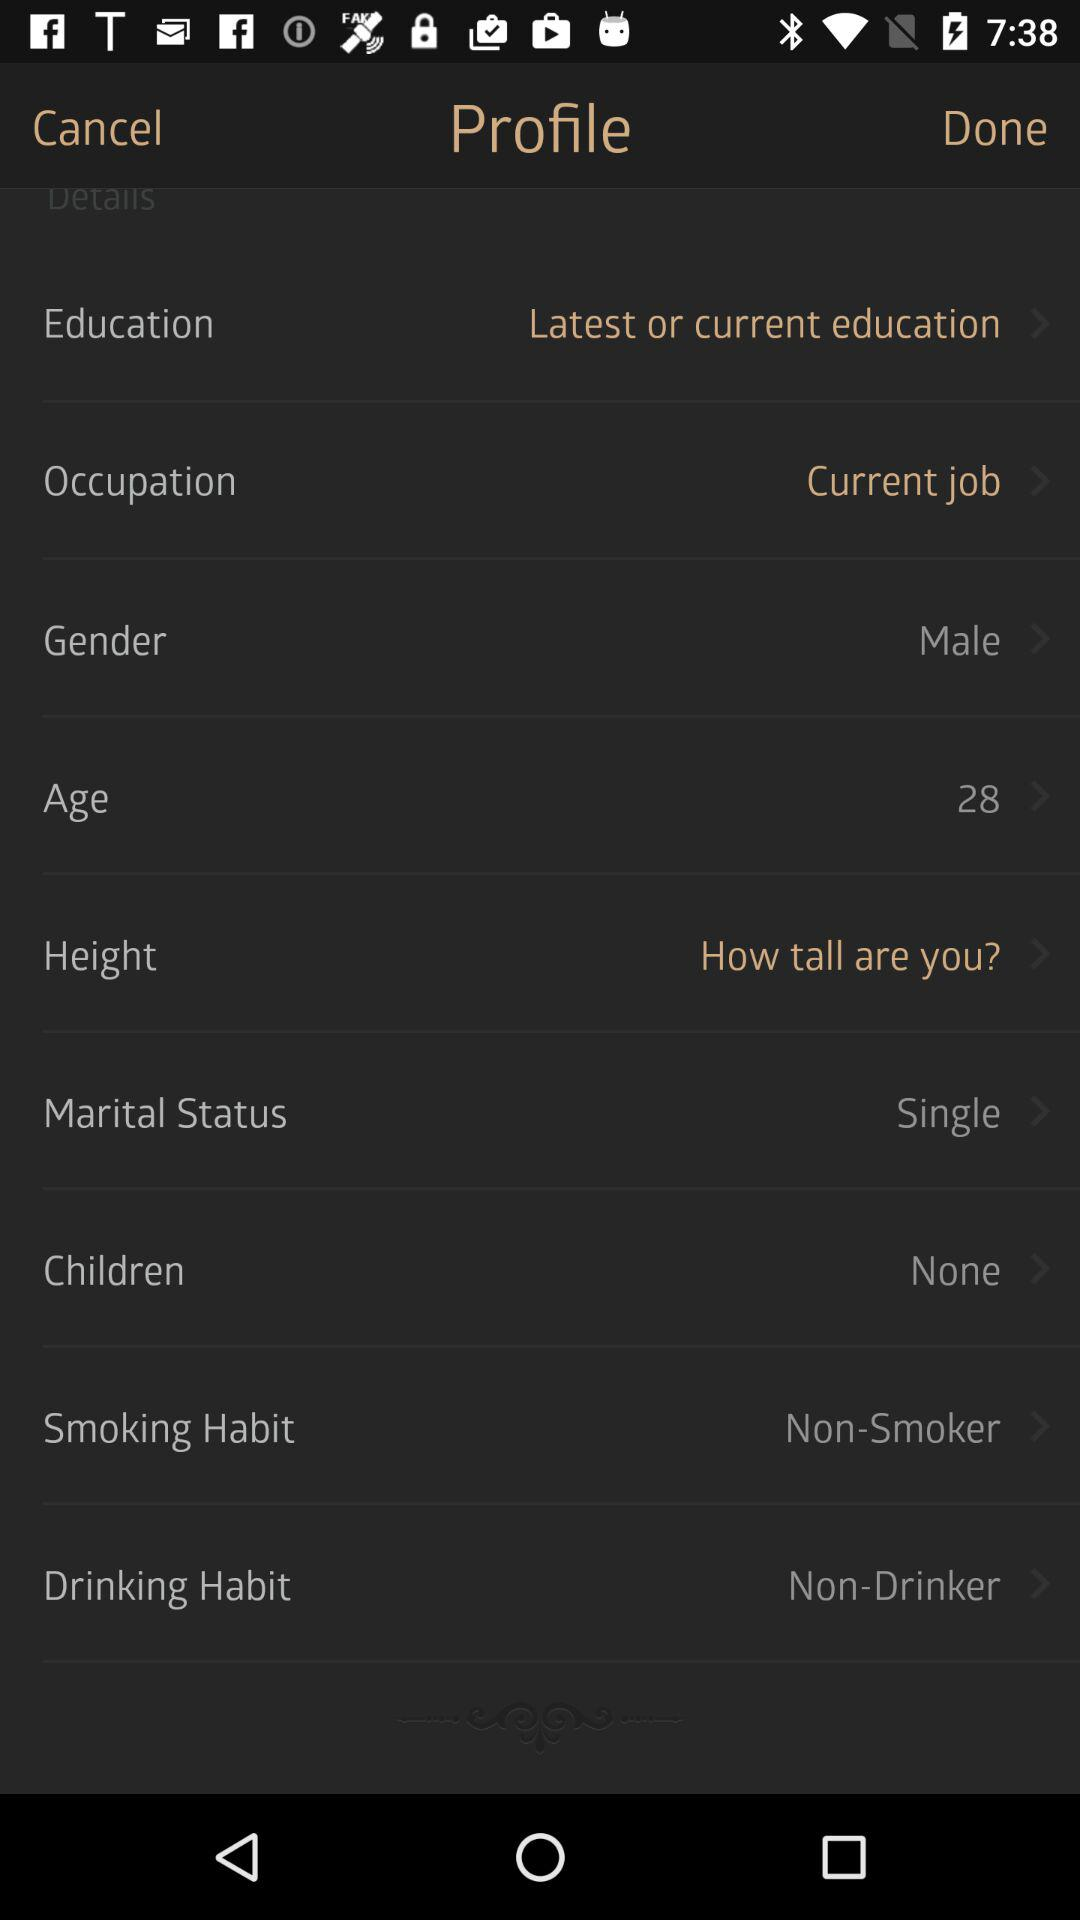What is the drinking habit? The drinking habit is "Non-Drinker". 